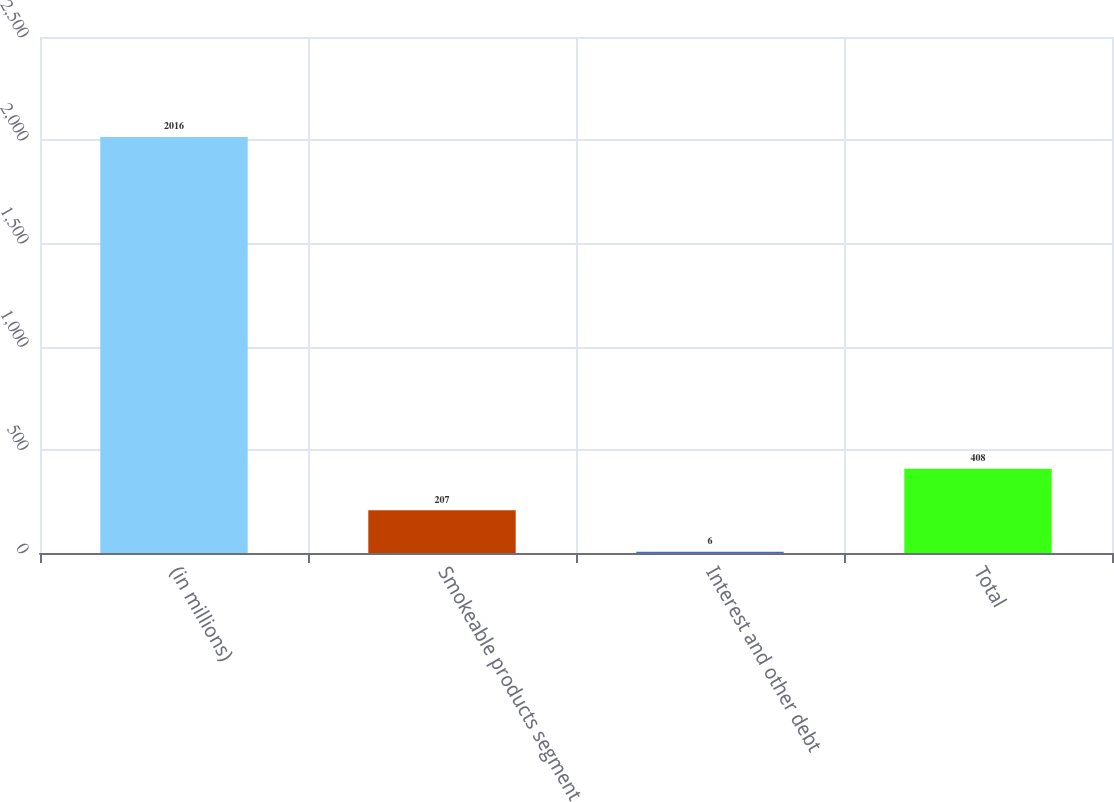Convert chart. <chart><loc_0><loc_0><loc_500><loc_500><bar_chart><fcel>(in millions)<fcel>Smokeable products segment<fcel>Interest and other debt<fcel>Total<nl><fcel>2016<fcel>207<fcel>6<fcel>408<nl></chart> 